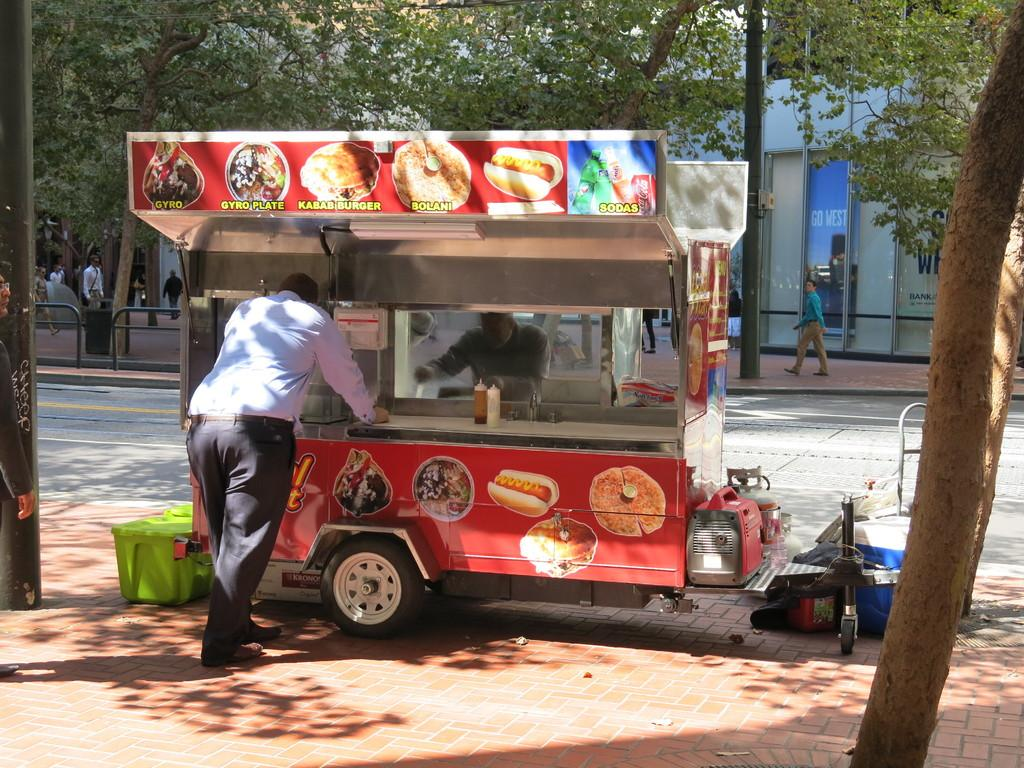What is the main subject of the image? The main subject of the image is a vehicle. What is attached to the vehicle? The vehicle has a board with food items on it. What can be seen in the background of the image? There are trees in the image. Who or what is present in the image? There are people in the image. What type of barrier is visible in the image? There is a fencing in the image. What is the temper of the man in the image? There is no man present in the image. What nation is represented by the food items on the board? The food items on the board do not represent any specific nation. 